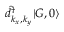Convert formula to latex. <formula><loc_0><loc_0><loc_500><loc_500>\hat { d } _ { k _ { x } , k _ { y } } ^ { \dagger } | G , 0 \rangle</formula> 